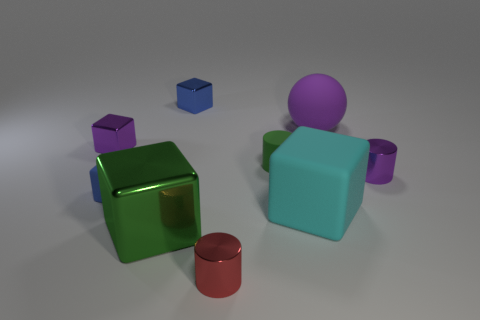What shape is the matte thing that is the same color as the large metal thing?
Provide a short and direct response. Cylinder. What number of metallic things are either yellow cylinders or tiny cubes?
Provide a succinct answer. 2. What material is the green thing that is in front of the small purple shiny object right of the small red cylinder?
Your response must be concise. Metal. Is the number of large cubes that are behind the big matte sphere greater than the number of purple rubber objects?
Provide a succinct answer. No. Is there a sphere that has the same material as the small purple cylinder?
Provide a short and direct response. No. There is a large matte object in front of the purple metal cylinder; is its shape the same as the green shiny thing?
Provide a short and direct response. Yes. There is a rubber cylinder that is in front of the large rubber object that is behind the matte cylinder; how many green blocks are behind it?
Provide a succinct answer. 0. Are there fewer big purple matte balls that are left of the small purple cube than green matte cylinders that are right of the rubber ball?
Your response must be concise. No. There is another tiny matte thing that is the same shape as the small red thing; what color is it?
Provide a succinct answer. Green. What size is the green cube?
Keep it short and to the point. Large. 